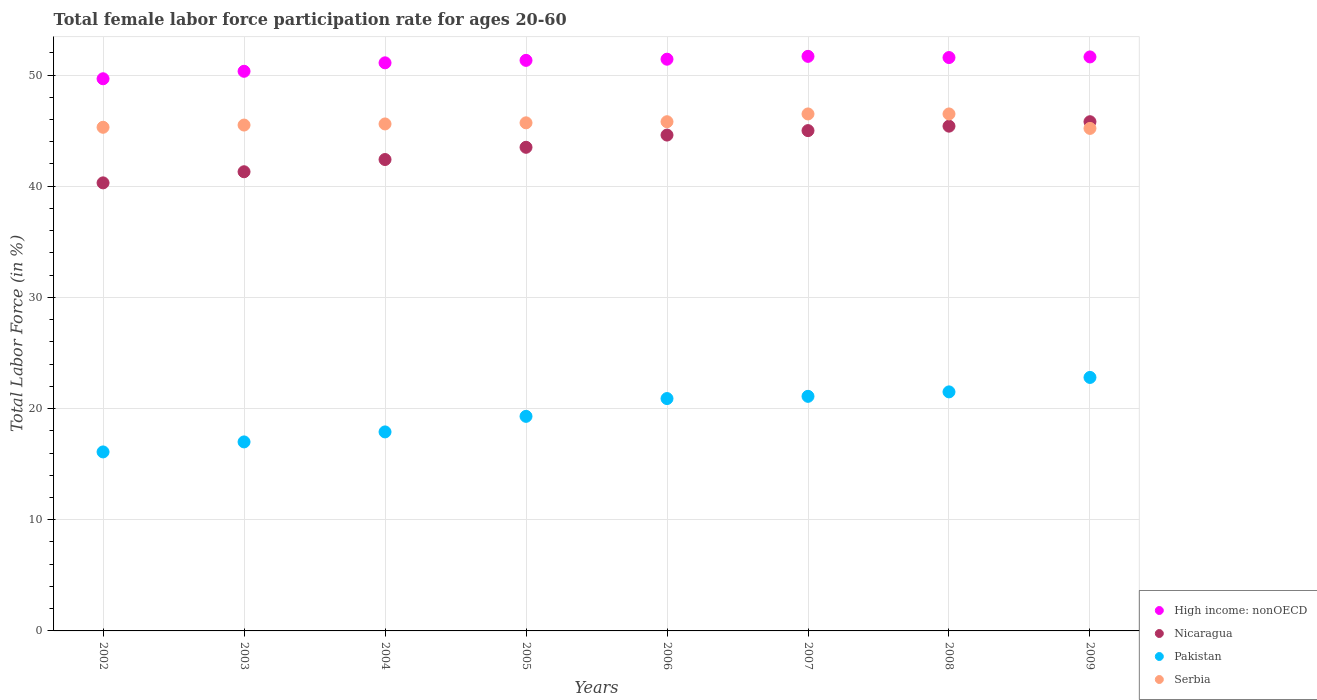How many different coloured dotlines are there?
Your response must be concise. 4. What is the female labor force participation rate in High income: nonOECD in 2003?
Your answer should be compact. 50.34. Across all years, what is the maximum female labor force participation rate in Serbia?
Offer a terse response. 46.5. Across all years, what is the minimum female labor force participation rate in Pakistan?
Ensure brevity in your answer.  16.1. In which year was the female labor force participation rate in Serbia maximum?
Ensure brevity in your answer.  2007. What is the total female labor force participation rate in Pakistan in the graph?
Provide a succinct answer. 156.6. What is the difference between the female labor force participation rate in Nicaragua in 2006 and that in 2008?
Make the answer very short. -0.8. What is the difference between the female labor force participation rate in Serbia in 2009 and the female labor force participation rate in Nicaragua in 2008?
Make the answer very short. -0.2. What is the average female labor force participation rate in Nicaragua per year?
Provide a succinct answer. 43.54. In the year 2005, what is the difference between the female labor force participation rate in Nicaragua and female labor force participation rate in High income: nonOECD?
Offer a terse response. -7.82. What is the ratio of the female labor force participation rate in Serbia in 2006 to that in 2009?
Your answer should be compact. 1.01. What is the difference between the highest and the second highest female labor force participation rate in Pakistan?
Provide a short and direct response. 1.3. What is the difference between the highest and the lowest female labor force participation rate in High income: nonOECD?
Offer a terse response. 2.02. In how many years, is the female labor force participation rate in High income: nonOECD greater than the average female labor force participation rate in High income: nonOECD taken over all years?
Provide a succinct answer. 6. Is it the case that in every year, the sum of the female labor force participation rate in Serbia and female labor force participation rate in Pakistan  is greater than the sum of female labor force participation rate in High income: nonOECD and female labor force participation rate in Nicaragua?
Your response must be concise. No. Is it the case that in every year, the sum of the female labor force participation rate in Nicaragua and female labor force participation rate in Pakistan  is greater than the female labor force participation rate in Serbia?
Give a very brief answer. Yes. How many dotlines are there?
Offer a terse response. 4. How many years are there in the graph?
Your response must be concise. 8. Are the values on the major ticks of Y-axis written in scientific E-notation?
Offer a very short reply. No. Does the graph contain grids?
Provide a succinct answer. Yes. Where does the legend appear in the graph?
Your answer should be very brief. Bottom right. How many legend labels are there?
Give a very brief answer. 4. What is the title of the graph?
Make the answer very short. Total female labor force participation rate for ages 20-60. What is the label or title of the Y-axis?
Give a very brief answer. Total Labor Force (in %). What is the Total Labor Force (in %) of High income: nonOECD in 2002?
Offer a terse response. 49.66. What is the Total Labor Force (in %) of Nicaragua in 2002?
Your answer should be very brief. 40.3. What is the Total Labor Force (in %) in Pakistan in 2002?
Make the answer very short. 16.1. What is the Total Labor Force (in %) in Serbia in 2002?
Your response must be concise. 45.3. What is the Total Labor Force (in %) in High income: nonOECD in 2003?
Ensure brevity in your answer.  50.34. What is the Total Labor Force (in %) of Nicaragua in 2003?
Make the answer very short. 41.3. What is the Total Labor Force (in %) in Pakistan in 2003?
Provide a succinct answer. 17. What is the Total Labor Force (in %) of Serbia in 2003?
Give a very brief answer. 45.5. What is the Total Labor Force (in %) of High income: nonOECD in 2004?
Ensure brevity in your answer.  51.1. What is the Total Labor Force (in %) of Nicaragua in 2004?
Offer a terse response. 42.4. What is the Total Labor Force (in %) of Pakistan in 2004?
Provide a short and direct response. 17.9. What is the Total Labor Force (in %) of Serbia in 2004?
Your answer should be compact. 45.6. What is the Total Labor Force (in %) of High income: nonOECD in 2005?
Your answer should be compact. 51.32. What is the Total Labor Force (in %) of Nicaragua in 2005?
Your answer should be compact. 43.5. What is the Total Labor Force (in %) in Pakistan in 2005?
Keep it short and to the point. 19.3. What is the Total Labor Force (in %) in Serbia in 2005?
Your answer should be very brief. 45.7. What is the Total Labor Force (in %) in High income: nonOECD in 2006?
Give a very brief answer. 51.42. What is the Total Labor Force (in %) in Nicaragua in 2006?
Ensure brevity in your answer.  44.6. What is the Total Labor Force (in %) in Pakistan in 2006?
Your answer should be compact. 20.9. What is the Total Labor Force (in %) in Serbia in 2006?
Give a very brief answer. 45.8. What is the Total Labor Force (in %) in High income: nonOECD in 2007?
Your answer should be very brief. 51.68. What is the Total Labor Force (in %) in Nicaragua in 2007?
Ensure brevity in your answer.  45. What is the Total Labor Force (in %) of Pakistan in 2007?
Give a very brief answer. 21.1. What is the Total Labor Force (in %) in Serbia in 2007?
Make the answer very short. 46.5. What is the Total Labor Force (in %) of High income: nonOECD in 2008?
Your answer should be very brief. 51.57. What is the Total Labor Force (in %) of Nicaragua in 2008?
Your answer should be very brief. 45.4. What is the Total Labor Force (in %) in Serbia in 2008?
Your answer should be compact. 46.5. What is the Total Labor Force (in %) in High income: nonOECD in 2009?
Ensure brevity in your answer.  51.63. What is the Total Labor Force (in %) in Nicaragua in 2009?
Keep it short and to the point. 45.8. What is the Total Labor Force (in %) in Pakistan in 2009?
Offer a terse response. 22.8. What is the Total Labor Force (in %) in Serbia in 2009?
Make the answer very short. 45.2. Across all years, what is the maximum Total Labor Force (in %) of High income: nonOECD?
Your response must be concise. 51.68. Across all years, what is the maximum Total Labor Force (in %) of Nicaragua?
Provide a short and direct response. 45.8. Across all years, what is the maximum Total Labor Force (in %) of Pakistan?
Ensure brevity in your answer.  22.8. Across all years, what is the maximum Total Labor Force (in %) in Serbia?
Your answer should be compact. 46.5. Across all years, what is the minimum Total Labor Force (in %) in High income: nonOECD?
Your answer should be compact. 49.66. Across all years, what is the minimum Total Labor Force (in %) of Nicaragua?
Your answer should be compact. 40.3. Across all years, what is the minimum Total Labor Force (in %) of Pakistan?
Provide a succinct answer. 16.1. Across all years, what is the minimum Total Labor Force (in %) in Serbia?
Give a very brief answer. 45.2. What is the total Total Labor Force (in %) in High income: nonOECD in the graph?
Offer a very short reply. 408.72. What is the total Total Labor Force (in %) of Nicaragua in the graph?
Give a very brief answer. 348.3. What is the total Total Labor Force (in %) in Pakistan in the graph?
Keep it short and to the point. 156.6. What is the total Total Labor Force (in %) in Serbia in the graph?
Offer a very short reply. 366.1. What is the difference between the Total Labor Force (in %) of High income: nonOECD in 2002 and that in 2003?
Offer a very short reply. -0.67. What is the difference between the Total Labor Force (in %) of Nicaragua in 2002 and that in 2003?
Provide a short and direct response. -1. What is the difference between the Total Labor Force (in %) in Pakistan in 2002 and that in 2003?
Your answer should be very brief. -0.9. What is the difference between the Total Labor Force (in %) of High income: nonOECD in 2002 and that in 2004?
Give a very brief answer. -1.43. What is the difference between the Total Labor Force (in %) of Pakistan in 2002 and that in 2004?
Provide a short and direct response. -1.8. What is the difference between the Total Labor Force (in %) of Serbia in 2002 and that in 2004?
Your response must be concise. -0.3. What is the difference between the Total Labor Force (in %) in High income: nonOECD in 2002 and that in 2005?
Your answer should be compact. -1.66. What is the difference between the Total Labor Force (in %) in Nicaragua in 2002 and that in 2005?
Your response must be concise. -3.2. What is the difference between the Total Labor Force (in %) in Pakistan in 2002 and that in 2005?
Offer a very short reply. -3.2. What is the difference between the Total Labor Force (in %) in High income: nonOECD in 2002 and that in 2006?
Make the answer very short. -1.76. What is the difference between the Total Labor Force (in %) in Nicaragua in 2002 and that in 2006?
Provide a short and direct response. -4.3. What is the difference between the Total Labor Force (in %) of Pakistan in 2002 and that in 2006?
Ensure brevity in your answer.  -4.8. What is the difference between the Total Labor Force (in %) in Serbia in 2002 and that in 2006?
Offer a terse response. -0.5. What is the difference between the Total Labor Force (in %) of High income: nonOECD in 2002 and that in 2007?
Provide a succinct answer. -2.02. What is the difference between the Total Labor Force (in %) of Pakistan in 2002 and that in 2007?
Your response must be concise. -5. What is the difference between the Total Labor Force (in %) of Serbia in 2002 and that in 2007?
Make the answer very short. -1.2. What is the difference between the Total Labor Force (in %) of High income: nonOECD in 2002 and that in 2008?
Offer a terse response. -1.91. What is the difference between the Total Labor Force (in %) of Pakistan in 2002 and that in 2008?
Keep it short and to the point. -5.4. What is the difference between the Total Labor Force (in %) in High income: nonOECD in 2002 and that in 2009?
Offer a terse response. -1.96. What is the difference between the Total Labor Force (in %) in Nicaragua in 2002 and that in 2009?
Provide a short and direct response. -5.5. What is the difference between the Total Labor Force (in %) of Pakistan in 2002 and that in 2009?
Your answer should be compact. -6.7. What is the difference between the Total Labor Force (in %) in Serbia in 2002 and that in 2009?
Keep it short and to the point. 0.1. What is the difference between the Total Labor Force (in %) of High income: nonOECD in 2003 and that in 2004?
Keep it short and to the point. -0.76. What is the difference between the Total Labor Force (in %) of High income: nonOECD in 2003 and that in 2005?
Ensure brevity in your answer.  -0.98. What is the difference between the Total Labor Force (in %) in Nicaragua in 2003 and that in 2005?
Your answer should be very brief. -2.2. What is the difference between the Total Labor Force (in %) in High income: nonOECD in 2003 and that in 2006?
Offer a very short reply. -1.09. What is the difference between the Total Labor Force (in %) of Nicaragua in 2003 and that in 2006?
Your response must be concise. -3.3. What is the difference between the Total Labor Force (in %) in High income: nonOECD in 2003 and that in 2007?
Keep it short and to the point. -1.34. What is the difference between the Total Labor Force (in %) in Serbia in 2003 and that in 2007?
Keep it short and to the point. -1. What is the difference between the Total Labor Force (in %) in High income: nonOECD in 2003 and that in 2008?
Provide a short and direct response. -1.24. What is the difference between the Total Labor Force (in %) in Serbia in 2003 and that in 2008?
Your answer should be compact. -1. What is the difference between the Total Labor Force (in %) in High income: nonOECD in 2003 and that in 2009?
Offer a terse response. -1.29. What is the difference between the Total Labor Force (in %) of Nicaragua in 2003 and that in 2009?
Your answer should be compact. -4.5. What is the difference between the Total Labor Force (in %) of Pakistan in 2003 and that in 2009?
Your answer should be compact. -5.8. What is the difference between the Total Labor Force (in %) in High income: nonOECD in 2004 and that in 2005?
Your response must be concise. -0.22. What is the difference between the Total Labor Force (in %) in Nicaragua in 2004 and that in 2005?
Give a very brief answer. -1.1. What is the difference between the Total Labor Force (in %) in High income: nonOECD in 2004 and that in 2006?
Keep it short and to the point. -0.33. What is the difference between the Total Labor Force (in %) in Serbia in 2004 and that in 2006?
Give a very brief answer. -0.2. What is the difference between the Total Labor Force (in %) of High income: nonOECD in 2004 and that in 2007?
Provide a short and direct response. -0.58. What is the difference between the Total Labor Force (in %) of High income: nonOECD in 2004 and that in 2008?
Your response must be concise. -0.48. What is the difference between the Total Labor Force (in %) in Nicaragua in 2004 and that in 2008?
Provide a succinct answer. -3. What is the difference between the Total Labor Force (in %) of Pakistan in 2004 and that in 2008?
Your answer should be compact. -3.6. What is the difference between the Total Labor Force (in %) of High income: nonOECD in 2004 and that in 2009?
Your answer should be compact. -0.53. What is the difference between the Total Labor Force (in %) in Nicaragua in 2004 and that in 2009?
Keep it short and to the point. -3.4. What is the difference between the Total Labor Force (in %) in Pakistan in 2004 and that in 2009?
Your answer should be very brief. -4.9. What is the difference between the Total Labor Force (in %) of Serbia in 2004 and that in 2009?
Offer a very short reply. 0.4. What is the difference between the Total Labor Force (in %) in High income: nonOECD in 2005 and that in 2006?
Your answer should be compact. -0.1. What is the difference between the Total Labor Force (in %) of Nicaragua in 2005 and that in 2006?
Keep it short and to the point. -1.1. What is the difference between the Total Labor Force (in %) in Serbia in 2005 and that in 2006?
Keep it short and to the point. -0.1. What is the difference between the Total Labor Force (in %) of High income: nonOECD in 2005 and that in 2007?
Keep it short and to the point. -0.36. What is the difference between the Total Labor Force (in %) of Pakistan in 2005 and that in 2007?
Your answer should be compact. -1.8. What is the difference between the Total Labor Force (in %) of High income: nonOECD in 2005 and that in 2008?
Provide a short and direct response. -0.25. What is the difference between the Total Labor Force (in %) in Nicaragua in 2005 and that in 2008?
Make the answer very short. -1.9. What is the difference between the Total Labor Force (in %) in Serbia in 2005 and that in 2008?
Offer a very short reply. -0.8. What is the difference between the Total Labor Force (in %) of High income: nonOECD in 2005 and that in 2009?
Offer a terse response. -0.31. What is the difference between the Total Labor Force (in %) in High income: nonOECD in 2006 and that in 2007?
Offer a very short reply. -0.26. What is the difference between the Total Labor Force (in %) of Nicaragua in 2006 and that in 2007?
Offer a terse response. -0.4. What is the difference between the Total Labor Force (in %) of Pakistan in 2006 and that in 2007?
Your answer should be very brief. -0.2. What is the difference between the Total Labor Force (in %) in High income: nonOECD in 2006 and that in 2008?
Provide a short and direct response. -0.15. What is the difference between the Total Labor Force (in %) in Serbia in 2006 and that in 2008?
Your answer should be very brief. -0.7. What is the difference between the Total Labor Force (in %) in High income: nonOECD in 2006 and that in 2009?
Provide a short and direct response. -0.2. What is the difference between the Total Labor Force (in %) of Nicaragua in 2006 and that in 2009?
Ensure brevity in your answer.  -1.2. What is the difference between the Total Labor Force (in %) in High income: nonOECD in 2007 and that in 2008?
Give a very brief answer. 0.11. What is the difference between the Total Labor Force (in %) in Nicaragua in 2007 and that in 2008?
Your answer should be compact. -0.4. What is the difference between the Total Labor Force (in %) in Serbia in 2007 and that in 2008?
Offer a very short reply. 0. What is the difference between the Total Labor Force (in %) of High income: nonOECD in 2007 and that in 2009?
Give a very brief answer. 0.05. What is the difference between the Total Labor Force (in %) of Nicaragua in 2007 and that in 2009?
Your response must be concise. -0.8. What is the difference between the Total Labor Force (in %) in High income: nonOECD in 2008 and that in 2009?
Provide a succinct answer. -0.06. What is the difference between the Total Labor Force (in %) of Pakistan in 2008 and that in 2009?
Give a very brief answer. -1.3. What is the difference between the Total Labor Force (in %) in Serbia in 2008 and that in 2009?
Provide a short and direct response. 1.3. What is the difference between the Total Labor Force (in %) in High income: nonOECD in 2002 and the Total Labor Force (in %) in Nicaragua in 2003?
Your answer should be compact. 8.36. What is the difference between the Total Labor Force (in %) of High income: nonOECD in 2002 and the Total Labor Force (in %) of Pakistan in 2003?
Offer a terse response. 32.66. What is the difference between the Total Labor Force (in %) of High income: nonOECD in 2002 and the Total Labor Force (in %) of Serbia in 2003?
Provide a succinct answer. 4.16. What is the difference between the Total Labor Force (in %) in Nicaragua in 2002 and the Total Labor Force (in %) in Pakistan in 2003?
Ensure brevity in your answer.  23.3. What is the difference between the Total Labor Force (in %) of Nicaragua in 2002 and the Total Labor Force (in %) of Serbia in 2003?
Keep it short and to the point. -5.2. What is the difference between the Total Labor Force (in %) of Pakistan in 2002 and the Total Labor Force (in %) of Serbia in 2003?
Keep it short and to the point. -29.4. What is the difference between the Total Labor Force (in %) of High income: nonOECD in 2002 and the Total Labor Force (in %) of Nicaragua in 2004?
Your response must be concise. 7.26. What is the difference between the Total Labor Force (in %) of High income: nonOECD in 2002 and the Total Labor Force (in %) of Pakistan in 2004?
Offer a very short reply. 31.76. What is the difference between the Total Labor Force (in %) in High income: nonOECD in 2002 and the Total Labor Force (in %) in Serbia in 2004?
Keep it short and to the point. 4.06. What is the difference between the Total Labor Force (in %) in Nicaragua in 2002 and the Total Labor Force (in %) in Pakistan in 2004?
Provide a short and direct response. 22.4. What is the difference between the Total Labor Force (in %) of Pakistan in 2002 and the Total Labor Force (in %) of Serbia in 2004?
Make the answer very short. -29.5. What is the difference between the Total Labor Force (in %) of High income: nonOECD in 2002 and the Total Labor Force (in %) of Nicaragua in 2005?
Offer a terse response. 6.16. What is the difference between the Total Labor Force (in %) in High income: nonOECD in 2002 and the Total Labor Force (in %) in Pakistan in 2005?
Your response must be concise. 30.36. What is the difference between the Total Labor Force (in %) in High income: nonOECD in 2002 and the Total Labor Force (in %) in Serbia in 2005?
Provide a succinct answer. 3.96. What is the difference between the Total Labor Force (in %) of Nicaragua in 2002 and the Total Labor Force (in %) of Pakistan in 2005?
Keep it short and to the point. 21. What is the difference between the Total Labor Force (in %) of Pakistan in 2002 and the Total Labor Force (in %) of Serbia in 2005?
Your answer should be very brief. -29.6. What is the difference between the Total Labor Force (in %) of High income: nonOECD in 2002 and the Total Labor Force (in %) of Nicaragua in 2006?
Offer a terse response. 5.06. What is the difference between the Total Labor Force (in %) in High income: nonOECD in 2002 and the Total Labor Force (in %) in Pakistan in 2006?
Keep it short and to the point. 28.76. What is the difference between the Total Labor Force (in %) of High income: nonOECD in 2002 and the Total Labor Force (in %) of Serbia in 2006?
Your answer should be compact. 3.86. What is the difference between the Total Labor Force (in %) of Pakistan in 2002 and the Total Labor Force (in %) of Serbia in 2006?
Your response must be concise. -29.7. What is the difference between the Total Labor Force (in %) of High income: nonOECD in 2002 and the Total Labor Force (in %) of Nicaragua in 2007?
Ensure brevity in your answer.  4.66. What is the difference between the Total Labor Force (in %) of High income: nonOECD in 2002 and the Total Labor Force (in %) of Pakistan in 2007?
Offer a terse response. 28.56. What is the difference between the Total Labor Force (in %) in High income: nonOECD in 2002 and the Total Labor Force (in %) in Serbia in 2007?
Offer a terse response. 3.16. What is the difference between the Total Labor Force (in %) of Nicaragua in 2002 and the Total Labor Force (in %) of Serbia in 2007?
Keep it short and to the point. -6.2. What is the difference between the Total Labor Force (in %) of Pakistan in 2002 and the Total Labor Force (in %) of Serbia in 2007?
Make the answer very short. -30.4. What is the difference between the Total Labor Force (in %) of High income: nonOECD in 2002 and the Total Labor Force (in %) of Nicaragua in 2008?
Offer a very short reply. 4.26. What is the difference between the Total Labor Force (in %) in High income: nonOECD in 2002 and the Total Labor Force (in %) in Pakistan in 2008?
Offer a terse response. 28.16. What is the difference between the Total Labor Force (in %) in High income: nonOECD in 2002 and the Total Labor Force (in %) in Serbia in 2008?
Provide a succinct answer. 3.16. What is the difference between the Total Labor Force (in %) in Nicaragua in 2002 and the Total Labor Force (in %) in Pakistan in 2008?
Provide a succinct answer. 18.8. What is the difference between the Total Labor Force (in %) of Pakistan in 2002 and the Total Labor Force (in %) of Serbia in 2008?
Provide a short and direct response. -30.4. What is the difference between the Total Labor Force (in %) of High income: nonOECD in 2002 and the Total Labor Force (in %) of Nicaragua in 2009?
Offer a very short reply. 3.86. What is the difference between the Total Labor Force (in %) in High income: nonOECD in 2002 and the Total Labor Force (in %) in Pakistan in 2009?
Your answer should be compact. 26.86. What is the difference between the Total Labor Force (in %) in High income: nonOECD in 2002 and the Total Labor Force (in %) in Serbia in 2009?
Give a very brief answer. 4.46. What is the difference between the Total Labor Force (in %) of Nicaragua in 2002 and the Total Labor Force (in %) of Pakistan in 2009?
Your answer should be very brief. 17.5. What is the difference between the Total Labor Force (in %) of Pakistan in 2002 and the Total Labor Force (in %) of Serbia in 2009?
Give a very brief answer. -29.1. What is the difference between the Total Labor Force (in %) in High income: nonOECD in 2003 and the Total Labor Force (in %) in Nicaragua in 2004?
Give a very brief answer. 7.94. What is the difference between the Total Labor Force (in %) of High income: nonOECD in 2003 and the Total Labor Force (in %) of Pakistan in 2004?
Your answer should be very brief. 32.44. What is the difference between the Total Labor Force (in %) in High income: nonOECD in 2003 and the Total Labor Force (in %) in Serbia in 2004?
Your answer should be very brief. 4.74. What is the difference between the Total Labor Force (in %) in Nicaragua in 2003 and the Total Labor Force (in %) in Pakistan in 2004?
Offer a very short reply. 23.4. What is the difference between the Total Labor Force (in %) of Nicaragua in 2003 and the Total Labor Force (in %) of Serbia in 2004?
Your answer should be very brief. -4.3. What is the difference between the Total Labor Force (in %) of Pakistan in 2003 and the Total Labor Force (in %) of Serbia in 2004?
Make the answer very short. -28.6. What is the difference between the Total Labor Force (in %) in High income: nonOECD in 2003 and the Total Labor Force (in %) in Nicaragua in 2005?
Your answer should be compact. 6.84. What is the difference between the Total Labor Force (in %) of High income: nonOECD in 2003 and the Total Labor Force (in %) of Pakistan in 2005?
Your response must be concise. 31.04. What is the difference between the Total Labor Force (in %) in High income: nonOECD in 2003 and the Total Labor Force (in %) in Serbia in 2005?
Your response must be concise. 4.64. What is the difference between the Total Labor Force (in %) of Nicaragua in 2003 and the Total Labor Force (in %) of Pakistan in 2005?
Make the answer very short. 22. What is the difference between the Total Labor Force (in %) in Pakistan in 2003 and the Total Labor Force (in %) in Serbia in 2005?
Your answer should be compact. -28.7. What is the difference between the Total Labor Force (in %) of High income: nonOECD in 2003 and the Total Labor Force (in %) of Nicaragua in 2006?
Make the answer very short. 5.74. What is the difference between the Total Labor Force (in %) of High income: nonOECD in 2003 and the Total Labor Force (in %) of Pakistan in 2006?
Provide a short and direct response. 29.44. What is the difference between the Total Labor Force (in %) in High income: nonOECD in 2003 and the Total Labor Force (in %) in Serbia in 2006?
Ensure brevity in your answer.  4.54. What is the difference between the Total Labor Force (in %) in Nicaragua in 2003 and the Total Labor Force (in %) in Pakistan in 2006?
Ensure brevity in your answer.  20.4. What is the difference between the Total Labor Force (in %) of Pakistan in 2003 and the Total Labor Force (in %) of Serbia in 2006?
Make the answer very short. -28.8. What is the difference between the Total Labor Force (in %) in High income: nonOECD in 2003 and the Total Labor Force (in %) in Nicaragua in 2007?
Keep it short and to the point. 5.34. What is the difference between the Total Labor Force (in %) of High income: nonOECD in 2003 and the Total Labor Force (in %) of Pakistan in 2007?
Provide a succinct answer. 29.24. What is the difference between the Total Labor Force (in %) of High income: nonOECD in 2003 and the Total Labor Force (in %) of Serbia in 2007?
Provide a succinct answer. 3.84. What is the difference between the Total Labor Force (in %) in Nicaragua in 2003 and the Total Labor Force (in %) in Pakistan in 2007?
Offer a very short reply. 20.2. What is the difference between the Total Labor Force (in %) in Pakistan in 2003 and the Total Labor Force (in %) in Serbia in 2007?
Make the answer very short. -29.5. What is the difference between the Total Labor Force (in %) of High income: nonOECD in 2003 and the Total Labor Force (in %) of Nicaragua in 2008?
Provide a succinct answer. 4.94. What is the difference between the Total Labor Force (in %) of High income: nonOECD in 2003 and the Total Labor Force (in %) of Pakistan in 2008?
Offer a terse response. 28.84. What is the difference between the Total Labor Force (in %) in High income: nonOECD in 2003 and the Total Labor Force (in %) in Serbia in 2008?
Keep it short and to the point. 3.84. What is the difference between the Total Labor Force (in %) of Nicaragua in 2003 and the Total Labor Force (in %) of Pakistan in 2008?
Your response must be concise. 19.8. What is the difference between the Total Labor Force (in %) of Nicaragua in 2003 and the Total Labor Force (in %) of Serbia in 2008?
Your answer should be compact. -5.2. What is the difference between the Total Labor Force (in %) of Pakistan in 2003 and the Total Labor Force (in %) of Serbia in 2008?
Provide a succinct answer. -29.5. What is the difference between the Total Labor Force (in %) of High income: nonOECD in 2003 and the Total Labor Force (in %) of Nicaragua in 2009?
Your response must be concise. 4.54. What is the difference between the Total Labor Force (in %) in High income: nonOECD in 2003 and the Total Labor Force (in %) in Pakistan in 2009?
Your answer should be compact. 27.54. What is the difference between the Total Labor Force (in %) of High income: nonOECD in 2003 and the Total Labor Force (in %) of Serbia in 2009?
Ensure brevity in your answer.  5.14. What is the difference between the Total Labor Force (in %) in Nicaragua in 2003 and the Total Labor Force (in %) in Pakistan in 2009?
Provide a short and direct response. 18.5. What is the difference between the Total Labor Force (in %) in Nicaragua in 2003 and the Total Labor Force (in %) in Serbia in 2009?
Your answer should be compact. -3.9. What is the difference between the Total Labor Force (in %) in Pakistan in 2003 and the Total Labor Force (in %) in Serbia in 2009?
Offer a terse response. -28.2. What is the difference between the Total Labor Force (in %) in High income: nonOECD in 2004 and the Total Labor Force (in %) in Nicaragua in 2005?
Provide a short and direct response. 7.6. What is the difference between the Total Labor Force (in %) of High income: nonOECD in 2004 and the Total Labor Force (in %) of Pakistan in 2005?
Give a very brief answer. 31.8. What is the difference between the Total Labor Force (in %) in High income: nonOECD in 2004 and the Total Labor Force (in %) in Serbia in 2005?
Provide a short and direct response. 5.4. What is the difference between the Total Labor Force (in %) of Nicaragua in 2004 and the Total Labor Force (in %) of Pakistan in 2005?
Give a very brief answer. 23.1. What is the difference between the Total Labor Force (in %) in Pakistan in 2004 and the Total Labor Force (in %) in Serbia in 2005?
Keep it short and to the point. -27.8. What is the difference between the Total Labor Force (in %) in High income: nonOECD in 2004 and the Total Labor Force (in %) in Nicaragua in 2006?
Provide a short and direct response. 6.5. What is the difference between the Total Labor Force (in %) of High income: nonOECD in 2004 and the Total Labor Force (in %) of Pakistan in 2006?
Keep it short and to the point. 30.2. What is the difference between the Total Labor Force (in %) in High income: nonOECD in 2004 and the Total Labor Force (in %) in Serbia in 2006?
Give a very brief answer. 5.3. What is the difference between the Total Labor Force (in %) in Nicaragua in 2004 and the Total Labor Force (in %) in Pakistan in 2006?
Your answer should be very brief. 21.5. What is the difference between the Total Labor Force (in %) of Nicaragua in 2004 and the Total Labor Force (in %) of Serbia in 2006?
Provide a short and direct response. -3.4. What is the difference between the Total Labor Force (in %) in Pakistan in 2004 and the Total Labor Force (in %) in Serbia in 2006?
Your answer should be very brief. -27.9. What is the difference between the Total Labor Force (in %) in High income: nonOECD in 2004 and the Total Labor Force (in %) in Nicaragua in 2007?
Offer a very short reply. 6.1. What is the difference between the Total Labor Force (in %) of High income: nonOECD in 2004 and the Total Labor Force (in %) of Pakistan in 2007?
Your answer should be very brief. 30. What is the difference between the Total Labor Force (in %) in High income: nonOECD in 2004 and the Total Labor Force (in %) in Serbia in 2007?
Your response must be concise. 4.6. What is the difference between the Total Labor Force (in %) in Nicaragua in 2004 and the Total Labor Force (in %) in Pakistan in 2007?
Your answer should be very brief. 21.3. What is the difference between the Total Labor Force (in %) in Pakistan in 2004 and the Total Labor Force (in %) in Serbia in 2007?
Your response must be concise. -28.6. What is the difference between the Total Labor Force (in %) in High income: nonOECD in 2004 and the Total Labor Force (in %) in Nicaragua in 2008?
Your answer should be very brief. 5.7. What is the difference between the Total Labor Force (in %) of High income: nonOECD in 2004 and the Total Labor Force (in %) of Pakistan in 2008?
Provide a short and direct response. 29.6. What is the difference between the Total Labor Force (in %) in High income: nonOECD in 2004 and the Total Labor Force (in %) in Serbia in 2008?
Your answer should be compact. 4.6. What is the difference between the Total Labor Force (in %) in Nicaragua in 2004 and the Total Labor Force (in %) in Pakistan in 2008?
Your response must be concise. 20.9. What is the difference between the Total Labor Force (in %) of Nicaragua in 2004 and the Total Labor Force (in %) of Serbia in 2008?
Give a very brief answer. -4.1. What is the difference between the Total Labor Force (in %) of Pakistan in 2004 and the Total Labor Force (in %) of Serbia in 2008?
Ensure brevity in your answer.  -28.6. What is the difference between the Total Labor Force (in %) in High income: nonOECD in 2004 and the Total Labor Force (in %) in Nicaragua in 2009?
Your answer should be compact. 5.3. What is the difference between the Total Labor Force (in %) of High income: nonOECD in 2004 and the Total Labor Force (in %) of Pakistan in 2009?
Provide a succinct answer. 28.3. What is the difference between the Total Labor Force (in %) of High income: nonOECD in 2004 and the Total Labor Force (in %) of Serbia in 2009?
Give a very brief answer. 5.9. What is the difference between the Total Labor Force (in %) of Nicaragua in 2004 and the Total Labor Force (in %) of Pakistan in 2009?
Offer a very short reply. 19.6. What is the difference between the Total Labor Force (in %) of Nicaragua in 2004 and the Total Labor Force (in %) of Serbia in 2009?
Provide a succinct answer. -2.8. What is the difference between the Total Labor Force (in %) of Pakistan in 2004 and the Total Labor Force (in %) of Serbia in 2009?
Your answer should be compact. -27.3. What is the difference between the Total Labor Force (in %) of High income: nonOECD in 2005 and the Total Labor Force (in %) of Nicaragua in 2006?
Your answer should be compact. 6.72. What is the difference between the Total Labor Force (in %) of High income: nonOECD in 2005 and the Total Labor Force (in %) of Pakistan in 2006?
Your response must be concise. 30.42. What is the difference between the Total Labor Force (in %) of High income: nonOECD in 2005 and the Total Labor Force (in %) of Serbia in 2006?
Offer a terse response. 5.52. What is the difference between the Total Labor Force (in %) in Nicaragua in 2005 and the Total Labor Force (in %) in Pakistan in 2006?
Make the answer very short. 22.6. What is the difference between the Total Labor Force (in %) in Pakistan in 2005 and the Total Labor Force (in %) in Serbia in 2006?
Ensure brevity in your answer.  -26.5. What is the difference between the Total Labor Force (in %) of High income: nonOECD in 2005 and the Total Labor Force (in %) of Nicaragua in 2007?
Offer a very short reply. 6.32. What is the difference between the Total Labor Force (in %) in High income: nonOECD in 2005 and the Total Labor Force (in %) in Pakistan in 2007?
Your answer should be very brief. 30.22. What is the difference between the Total Labor Force (in %) of High income: nonOECD in 2005 and the Total Labor Force (in %) of Serbia in 2007?
Ensure brevity in your answer.  4.82. What is the difference between the Total Labor Force (in %) of Nicaragua in 2005 and the Total Labor Force (in %) of Pakistan in 2007?
Your response must be concise. 22.4. What is the difference between the Total Labor Force (in %) of Pakistan in 2005 and the Total Labor Force (in %) of Serbia in 2007?
Provide a succinct answer. -27.2. What is the difference between the Total Labor Force (in %) of High income: nonOECD in 2005 and the Total Labor Force (in %) of Nicaragua in 2008?
Your response must be concise. 5.92. What is the difference between the Total Labor Force (in %) in High income: nonOECD in 2005 and the Total Labor Force (in %) in Pakistan in 2008?
Offer a terse response. 29.82. What is the difference between the Total Labor Force (in %) of High income: nonOECD in 2005 and the Total Labor Force (in %) of Serbia in 2008?
Give a very brief answer. 4.82. What is the difference between the Total Labor Force (in %) of Nicaragua in 2005 and the Total Labor Force (in %) of Pakistan in 2008?
Offer a very short reply. 22. What is the difference between the Total Labor Force (in %) in Pakistan in 2005 and the Total Labor Force (in %) in Serbia in 2008?
Provide a short and direct response. -27.2. What is the difference between the Total Labor Force (in %) of High income: nonOECD in 2005 and the Total Labor Force (in %) of Nicaragua in 2009?
Provide a succinct answer. 5.52. What is the difference between the Total Labor Force (in %) of High income: nonOECD in 2005 and the Total Labor Force (in %) of Pakistan in 2009?
Make the answer very short. 28.52. What is the difference between the Total Labor Force (in %) in High income: nonOECD in 2005 and the Total Labor Force (in %) in Serbia in 2009?
Your response must be concise. 6.12. What is the difference between the Total Labor Force (in %) of Nicaragua in 2005 and the Total Labor Force (in %) of Pakistan in 2009?
Provide a succinct answer. 20.7. What is the difference between the Total Labor Force (in %) in Pakistan in 2005 and the Total Labor Force (in %) in Serbia in 2009?
Your answer should be compact. -25.9. What is the difference between the Total Labor Force (in %) of High income: nonOECD in 2006 and the Total Labor Force (in %) of Nicaragua in 2007?
Your answer should be very brief. 6.42. What is the difference between the Total Labor Force (in %) of High income: nonOECD in 2006 and the Total Labor Force (in %) of Pakistan in 2007?
Keep it short and to the point. 30.32. What is the difference between the Total Labor Force (in %) in High income: nonOECD in 2006 and the Total Labor Force (in %) in Serbia in 2007?
Your answer should be very brief. 4.92. What is the difference between the Total Labor Force (in %) in Nicaragua in 2006 and the Total Labor Force (in %) in Serbia in 2007?
Give a very brief answer. -1.9. What is the difference between the Total Labor Force (in %) of Pakistan in 2006 and the Total Labor Force (in %) of Serbia in 2007?
Your answer should be very brief. -25.6. What is the difference between the Total Labor Force (in %) of High income: nonOECD in 2006 and the Total Labor Force (in %) of Nicaragua in 2008?
Your answer should be very brief. 6.02. What is the difference between the Total Labor Force (in %) of High income: nonOECD in 2006 and the Total Labor Force (in %) of Pakistan in 2008?
Your response must be concise. 29.92. What is the difference between the Total Labor Force (in %) of High income: nonOECD in 2006 and the Total Labor Force (in %) of Serbia in 2008?
Keep it short and to the point. 4.92. What is the difference between the Total Labor Force (in %) of Nicaragua in 2006 and the Total Labor Force (in %) of Pakistan in 2008?
Give a very brief answer. 23.1. What is the difference between the Total Labor Force (in %) in Pakistan in 2006 and the Total Labor Force (in %) in Serbia in 2008?
Offer a very short reply. -25.6. What is the difference between the Total Labor Force (in %) in High income: nonOECD in 2006 and the Total Labor Force (in %) in Nicaragua in 2009?
Keep it short and to the point. 5.62. What is the difference between the Total Labor Force (in %) of High income: nonOECD in 2006 and the Total Labor Force (in %) of Pakistan in 2009?
Keep it short and to the point. 28.62. What is the difference between the Total Labor Force (in %) of High income: nonOECD in 2006 and the Total Labor Force (in %) of Serbia in 2009?
Offer a very short reply. 6.22. What is the difference between the Total Labor Force (in %) in Nicaragua in 2006 and the Total Labor Force (in %) in Pakistan in 2009?
Keep it short and to the point. 21.8. What is the difference between the Total Labor Force (in %) of Nicaragua in 2006 and the Total Labor Force (in %) of Serbia in 2009?
Offer a very short reply. -0.6. What is the difference between the Total Labor Force (in %) of Pakistan in 2006 and the Total Labor Force (in %) of Serbia in 2009?
Your answer should be very brief. -24.3. What is the difference between the Total Labor Force (in %) of High income: nonOECD in 2007 and the Total Labor Force (in %) of Nicaragua in 2008?
Make the answer very short. 6.28. What is the difference between the Total Labor Force (in %) in High income: nonOECD in 2007 and the Total Labor Force (in %) in Pakistan in 2008?
Offer a terse response. 30.18. What is the difference between the Total Labor Force (in %) in High income: nonOECD in 2007 and the Total Labor Force (in %) in Serbia in 2008?
Give a very brief answer. 5.18. What is the difference between the Total Labor Force (in %) in Pakistan in 2007 and the Total Labor Force (in %) in Serbia in 2008?
Your response must be concise. -25.4. What is the difference between the Total Labor Force (in %) of High income: nonOECD in 2007 and the Total Labor Force (in %) of Nicaragua in 2009?
Provide a succinct answer. 5.88. What is the difference between the Total Labor Force (in %) of High income: nonOECD in 2007 and the Total Labor Force (in %) of Pakistan in 2009?
Your answer should be compact. 28.88. What is the difference between the Total Labor Force (in %) in High income: nonOECD in 2007 and the Total Labor Force (in %) in Serbia in 2009?
Your answer should be compact. 6.48. What is the difference between the Total Labor Force (in %) of Nicaragua in 2007 and the Total Labor Force (in %) of Pakistan in 2009?
Offer a terse response. 22.2. What is the difference between the Total Labor Force (in %) of Nicaragua in 2007 and the Total Labor Force (in %) of Serbia in 2009?
Keep it short and to the point. -0.2. What is the difference between the Total Labor Force (in %) in Pakistan in 2007 and the Total Labor Force (in %) in Serbia in 2009?
Your answer should be very brief. -24.1. What is the difference between the Total Labor Force (in %) in High income: nonOECD in 2008 and the Total Labor Force (in %) in Nicaragua in 2009?
Offer a very short reply. 5.77. What is the difference between the Total Labor Force (in %) of High income: nonOECD in 2008 and the Total Labor Force (in %) of Pakistan in 2009?
Give a very brief answer. 28.77. What is the difference between the Total Labor Force (in %) in High income: nonOECD in 2008 and the Total Labor Force (in %) in Serbia in 2009?
Your response must be concise. 6.37. What is the difference between the Total Labor Force (in %) of Nicaragua in 2008 and the Total Labor Force (in %) of Pakistan in 2009?
Keep it short and to the point. 22.6. What is the difference between the Total Labor Force (in %) of Pakistan in 2008 and the Total Labor Force (in %) of Serbia in 2009?
Your answer should be compact. -23.7. What is the average Total Labor Force (in %) of High income: nonOECD per year?
Your response must be concise. 51.09. What is the average Total Labor Force (in %) of Nicaragua per year?
Offer a terse response. 43.54. What is the average Total Labor Force (in %) in Pakistan per year?
Provide a short and direct response. 19.57. What is the average Total Labor Force (in %) of Serbia per year?
Offer a terse response. 45.76. In the year 2002, what is the difference between the Total Labor Force (in %) in High income: nonOECD and Total Labor Force (in %) in Nicaragua?
Your response must be concise. 9.36. In the year 2002, what is the difference between the Total Labor Force (in %) of High income: nonOECD and Total Labor Force (in %) of Pakistan?
Make the answer very short. 33.56. In the year 2002, what is the difference between the Total Labor Force (in %) in High income: nonOECD and Total Labor Force (in %) in Serbia?
Your response must be concise. 4.36. In the year 2002, what is the difference between the Total Labor Force (in %) in Nicaragua and Total Labor Force (in %) in Pakistan?
Keep it short and to the point. 24.2. In the year 2002, what is the difference between the Total Labor Force (in %) of Pakistan and Total Labor Force (in %) of Serbia?
Ensure brevity in your answer.  -29.2. In the year 2003, what is the difference between the Total Labor Force (in %) in High income: nonOECD and Total Labor Force (in %) in Nicaragua?
Provide a short and direct response. 9.04. In the year 2003, what is the difference between the Total Labor Force (in %) in High income: nonOECD and Total Labor Force (in %) in Pakistan?
Your response must be concise. 33.34. In the year 2003, what is the difference between the Total Labor Force (in %) in High income: nonOECD and Total Labor Force (in %) in Serbia?
Offer a terse response. 4.84. In the year 2003, what is the difference between the Total Labor Force (in %) in Nicaragua and Total Labor Force (in %) in Pakistan?
Your answer should be very brief. 24.3. In the year 2003, what is the difference between the Total Labor Force (in %) in Nicaragua and Total Labor Force (in %) in Serbia?
Give a very brief answer. -4.2. In the year 2003, what is the difference between the Total Labor Force (in %) of Pakistan and Total Labor Force (in %) of Serbia?
Provide a short and direct response. -28.5. In the year 2004, what is the difference between the Total Labor Force (in %) in High income: nonOECD and Total Labor Force (in %) in Nicaragua?
Your response must be concise. 8.7. In the year 2004, what is the difference between the Total Labor Force (in %) in High income: nonOECD and Total Labor Force (in %) in Pakistan?
Keep it short and to the point. 33.2. In the year 2004, what is the difference between the Total Labor Force (in %) in High income: nonOECD and Total Labor Force (in %) in Serbia?
Offer a very short reply. 5.5. In the year 2004, what is the difference between the Total Labor Force (in %) of Nicaragua and Total Labor Force (in %) of Serbia?
Give a very brief answer. -3.2. In the year 2004, what is the difference between the Total Labor Force (in %) of Pakistan and Total Labor Force (in %) of Serbia?
Keep it short and to the point. -27.7. In the year 2005, what is the difference between the Total Labor Force (in %) of High income: nonOECD and Total Labor Force (in %) of Nicaragua?
Your answer should be compact. 7.82. In the year 2005, what is the difference between the Total Labor Force (in %) of High income: nonOECD and Total Labor Force (in %) of Pakistan?
Provide a short and direct response. 32.02. In the year 2005, what is the difference between the Total Labor Force (in %) of High income: nonOECD and Total Labor Force (in %) of Serbia?
Your response must be concise. 5.62. In the year 2005, what is the difference between the Total Labor Force (in %) of Nicaragua and Total Labor Force (in %) of Pakistan?
Offer a very short reply. 24.2. In the year 2005, what is the difference between the Total Labor Force (in %) of Nicaragua and Total Labor Force (in %) of Serbia?
Offer a terse response. -2.2. In the year 2005, what is the difference between the Total Labor Force (in %) in Pakistan and Total Labor Force (in %) in Serbia?
Provide a succinct answer. -26.4. In the year 2006, what is the difference between the Total Labor Force (in %) of High income: nonOECD and Total Labor Force (in %) of Nicaragua?
Offer a very short reply. 6.82. In the year 2006, what is the difference between the Total Labor Force (in %) of High income: nonOECD and Total Labor Force (in %) of Pakistan?
Keep it short and to the point. 30.52. In the year 2006, what is the difference between the Total Labor Force (in %) in High income: nonOECD and Total Labor Force (in %) in Serbia?
Provide a succinct answer. 5.62. In the year 2006, what is the difference between the Total Labor Force (in %) of Nicaragua and Total Labor Force (in %) of Pakistan?
Keep it short and to the point. 23.7. In the year 2006, what is the difference between the Total Labor Force (in %) in Pakistan and Total Labor Force (in %) in Serbia?
Offer a very short reply. -24.9. In the year 2007, what is the difference between the Total Labor Force (in %) in High income: nonOECD and Total Labor Force (in %) in Nicaragua?
Keep it short and to the point. 6.68. In the year 2007, what is the difference between the Total Labor Force (in %) of High income: nonOECD and Total Labor Force (in %) of Pakistan?
Your answer should be very brief. 30.58. In the year 2007, what is the difference between the Total Labor Force (in %) of High income: nonOECD and Total Labor Force (in %) of Serbia?
Your answer should be very brief. 5.18. In the year 2007, what is the difference between the Total Labor Force (in %) in Nicaragua and Total Labor Force (in %) in Pakistan?
Keep it short and to the point. 23.9. In the year 2007, what is the difference between the Total Labor Force (in %) of Nicaragua and Total Labor Force (in %) of Serbia?
Your answer should be very brief. -1.5. In the year 2007, what is the difference between the Total Labor Force (in %) of Pakistan and Total Labor Force (in %) of Serbia?
Provide a short and direct response. -25.4. In the year 2008, what is the difference between the Total Labor Force (in %) in High income: nonOECD and Total Labor Force (in %) in Nicaragua?
Provide a short and direct response. 6.17. In the year 2008, what is the difference between the Total Labor Force (in %) of High income: nonOECD and Total Labor Force (in %) of Pakistan?
Give a very brief answer. 30.07. In the year 2008, what is the difference between the Total Labor Force (in %) of High income: nonOECD and Total Labor Force (in %) of Serbia?
Ensure brevity in your answer.  5.07. In the year 2008, what is the difference between the Total Labor Force (in %) of Nicaragua and Total Labor Force (in %) of Pakistan?
Provide a short and direct response. 23.9. In the year 2008, what is the difference between the Total Labor Force (in %) of Nicaragua and Total Labor Force (in %) of Serbia?
Your answer should be very brief. -1.1. In the year 2008, what is the difference between the Total Labor Force (in %) in Pakistan and Total Labor Force (in %) in Serbia?
Keep it short and to the point. -25. In the year 2009, what is the difference between the Total Labor Force (in %) in High income: nonOECD and Total Labor Force (in %) in Nicaragua?
Give a very brief answer. 5.83. In the year 2009, what is the difference between the Total Labor Force (in %) in High income: nonOECD and Total Labor Force (in %) in Pakistan?
Provide a succinct answer. 28.83. In the year 2009, what is the difference between the Total Labor Force (in %) in High income: nonOECD and Total Labor Force (in %) in Serbia?
Offer a terse response. 6.43. In the year 2009, what is the difference between the Total Labor Force (in %) in Nicaragua and Total Labor Force (in %) in Pakistan?
Keep it short and to the point. 23. In the year 2009, what is the difference between the Total Labor Force (in %) in Nicaragua and Total Labor Force (in %) in Serbia?
Provide a short and direct response. 0.6. In the year 2009, what is the difference between the Total Labor Force (in %) in Pakistan and Total Labor Force (in %) in Serbia?
Offer a terse response. -22.4. What is the ratio of the Total Labor Force (in %) in High income: nonOECD in 2002 to that in 2003?
Offer a terse response. 0.99. What is the ratio of the Total Labor Force (in %) of Nicaragua in 2002 to that in 2003?
Make the answer very short. 0.98. What is the ratio of the Total Labor Force (in %) in Pakistan in 2002 to that in 2003?
Provide a short and direct response. 0.95. What is the ratio of the Total Labor Force (in %) of Serbia in 2002 to that in 2003?
Your response must be concise. 1. What is the ratio of the Total Labor Force (in %) in High income: nonOECD in 2002 to that in 2004?
Your answer should be compact. 0.97. What is the ratio of the Total Labor Force (in %) of Nicaragua in 2002 to that in 2004?
Provide a succinct answer. 0.95. What is the ratio of the Total Labor Force (in %) of Pakistan in 2002 to that in 2004?
Make the answer very short. 0.9. What is the ratio of the Total Labor Force (in %) in Serbia in 2002 to that in 2004?
Offer a terse response. 0.99. What is the ratio of the Total Labor Force (in %) of Nicaragua in 2002 to that in 2005?
Keep it short and to the point. 0.93. What is the ratio of the Total Labor Force (in %) in Pakistan in 2002 to that in 2005?
Your response must be concise. 0.83. What is the ratio of the Total Labor Force (in %) in Serbia in 2002 to that in 2005?
Ensure brevity in your answer.  0.99. What is the ratio of the Total Labor Force (in %) in High income: nonOECD in 2002 to that in 2006?
Provide a short and direct response. 0.97. What is the ratio of the Total Labor Force (in %) in Nicaragua in 2002 to that in 2006?
Your answer should be compact. 0.9. What is the ratio of the Total Labor Force (in %) in Pakistan in 2002 to that in 2006?
Your answer should be very brief. 0.77. What is the ratio of the Total Labor Force (in %) of Serbia in 2002 to that in 2006?
Provide a succinct answer. 0.99. What is the ratio of the Total Labor Force (in %) of Nicaragua in 2002 to that in 2007?
Your response must be concise. 0.9. What is the ratio of the Total Labor Force (in %) in Pakistan in 2002 to that in 2007?
Offer a terse response. 0.76. What is the ratio of the Total Labor Force (in %) in Serbia in 2002 to that in 2007?
Provide a short and direct response. 0.97. What is the ratio of the Total Labor Force (in %) in Nicaragua in 2002 to that in 2008?
Your response must be concise. 0.89. What is the ratio of the Total Labor Force (in %) in Pakistan in 2002 to that in 2008?
Give a very brief answer. 0.75. What is the ratio of the Total Labor Force (in %) in Serbia in 2002 to that in 2008?
Keep it short and to the point. 0.97. What is the ratio of the Total Labor Force (in %) of High income: nonOECD in 2002 to that in 2009?
Offer a terse response. 0.96. What is the ratio of the Total Labor Force (in %) in Nicaragua in 2002 to that in 2009?
Provide a succinct answer. 0.88. What is the ratio of the Total Labor Force (in %) of Pakistan in 2002 to that in 2009?
Ensure brevity in your answer.  0.71. What is the ratio of the Total Labor Force (in %) in High income: nonOECD in 2003 to that in 2004?
Offer a terse response. 0.99. What is the ratio of the Total Labor Force (in %) in Nicaragua in 2003 to that in 2004?
Offer a terse response. 0.97. What is the ratio of the Total Labor Force (in %) of Pakistan in 2003 to that in 2004?
Your response must be concise. 0.95. What is the ratio of the Total Labor Force (in %) in High income: nonOECD in 2003 to that in 2005?
Provide a short and direct response. 0.98. What is the ratio of the Total Labor Force (in %) in Nicaragua in 2003 to that in 2005?
Offer a very short reply. 0.95. What is the ratio of the Total Labor Force (in %) of Pakistan in 2003 to that in 2005?
Offer a terse response. 0.88. What is the ratio of the Total Labor Force (in %) in High income: nonOECD in 2003 to that in 2006?
Offer a very short reply. 0.98. What is the ratio of the Total Labor Force (in %) in Nicaragua in 2003 to that in 2006?
Provide a short and direct response. 0.93. What is the ratio of the Total Labor Force (in %) in Pakistan in 2003 to that in 2006?
Your answer should be compact. 0.81. What is the ratio of the Total Labor Force (in %) of Serbia in 2003 to that in 2006?
Offer a terse response. 0.99. What is the ratio of the Total Labor Force (in %) in High income: nonOECD in 2003 to that in 2007?
Your answer should be compact. 0.97. What is the ratio of the Total Labor Force (in %) of Nicaragua in 2003 to that in 2007?
Give a very brief answer. 0.92. What is the ratio of the Total Labor Force (in %) of Pakistan in 2003 to that in 2007?
Offer a terse response. 0.81. What is the ratio of the Total Labor Force (in %) of Serbia in 2003 to that in 2007?
Keep it short and to the point. 0.98. What is the ratio of the Total Labor Force (in %) of High income: nonOECD in 2003 to that in 2008?
Your answer should be compact. 0.98. What is the ratio of the Total Labor Force (in %) of Nicaragua in 2003 to that in 2008?
Give a very brief answer. 0.91. What is the ratio of the Total Labor Force (in %) in Pakistan in 2003 to that in 2008?
Provide a succinct answer. 0.79. What is the ratio of the Total Labor Force (in %) in Serbia in 2003 to that in 2008?
Offer a very short reply. 0.98. What is the ratio of the Total Labor Force (in %) in High income: nonOECD in 2003 to that in 2009?
Offer a very short reply. 0.97. What is the ratio of the Total Labor Force (in %) of Nicaragua in 2003 to that in 2009?
Offer a very short reply. 0.9. What is the ratio of the Total Labor Force (in %) of Pakistan in 2003 to that in 2009?
Your answer should be compact. 0.75. What is the ratio of the Total Labor Force (in %) in Serbia in 2003 to that in 2009?
Your answer should be very brief. 1.01. What is the ratio of the Total Labor Force (in %) in High income: nonOECD in 2004 to that in 2005?
Ensure brevity in your answer.  1. What is the ratio of the Total Labor Force (in %) of Nicaragua in 2004 to that in 2005?
Your response must be concise. 0.97. What is the ratio of the Total Labor Force (in %) in Pakistan in 2004 to that in 2005?
Ensure brevity in your answer.  0.93. What is the ratio of the Total Labor Force (in %) of High income: nonOECD in 2004 to that in 2006?
Your response must be concise. 0.99. What is the ratio of the Total Labor Force (in %) in Nicaragua in 2004 to that in 2006?
Make the answer very short. 0.95. What is the ratio of the Total Labor Force (in %) of Pakistan in 2004 to that in 2006?
Make the answer very short. 0.86. What is the ratio of the Total Labor Force (in %) of Serbia in 2004 to that in 2006?
Your answer should be compact. 1. What is the ratio of the Total Labor Force (in %) in High income: nonOECD in 2004 to that in 2007?
Ensure brevity in your answer.  0.99. What is the ratio of the Total Labor Force (in %) in Nicaragua in 2004 to that in 2007?
Give a very brief answer. 0.94. What is the ratio of the Total Labor Force (in %) of Pakistan in 2004 to that in 2007?
Keep it short and to the point. 0.85. What is the ratio of the Total Labor Force (in %) of Serbia in 2004 to that in 2007?
Provide a succinct answer. 0.98. What is the ratio of the Total Labor Force (in %) of Nicaragua in 2004 to that in 2008?
Offer a terse response. 0.93. What is the ratio of the Total Labor Force (in %) in Pakistan in 2004 to that in 2008?
Give a very brief answer. 0.83. What is the ratio of the Total Labor Force (in %) in Serbia in 2004 to that in 2008?
Offer a terse response. 0.98. What is the ratio of the Total Labor Force (in %) of Nicaragua in 2004 to that in 2009?
Offer a very short reply. 0.93. What is the ratio of the Total Labor Force (in %) in Pakistan in 2004 to that in 2009?
Your answer should be compact. 0.79. What is the ratio of the Total Labor Force (in %) in Serbia in 2004 to that in 2009?
Offer a very short reply. 1.01. What is the ratio of the Total Labor Force (in %) in High income: nonOECD in 2005 to that in 2006?
Offer a very short reply. 1. What is the ratio of the Total Labor Force (in %) of Nicaragua in 2005 to that in 2006?
Give a very brief answer. 0.98. What is the ratio of the Total Labor Force (in %) of Pakistan in 2005 to that in 2006?
Keep it short and to the point. 0.92. What is the ratio of the Total Labor Force (in %) of High income: nonOECD in 2005 to that in 2007?
Ensure brevity in your answer.  0.99. What is the ratio of the Total Labor Force (in %) of Nicaragua in 2005 to that in 2007?
Offer a terse response. 0.97. What is the ratio of the Total Labor Force (in %) in Pakistan in 2005 to that in 2007?
Your answer should be very brief. 0.91. What is the ratio of the Total Labor Force (in %) of Serbia in 2005 to that in 2007?
Give a very brief answer. 0.98. What is the ratio of the Total Labor Force (in %) of Nicaragua in 2005 to that in 2008?
Give a very brief answer. 0.96. What is the ratio of the Total Labor Force (in %) in Pakistan in 2005 to that in 2008?
Make the answer very short. 0.9. What is the ratio of the Total Labor Force (in %) in Serbia in 2005 to that in 2008?
Your answer should be very brief. 0.98. What is the ratio of the Total Labor Force (in %) of Nicaragua in 2005 to that in 2009?
Give a very brief answer. 0.95. What is the ratio of the Total Labor Force (in %) of Pakistan in 2005 to that in 2009?
Provide a succinct answer. 0.85. What is the ratio of the Total Labor Force (in %) of Serbia in 2005 to that in 2009?
Offer a very short reply. 1.01. What is the ratio of the Total Labor Force (in %) of High income: nonOECD in 2006 to that in 2007?
Your answer should be very brief. 1. What is the ratio of the Total Labor Force (in %) of Serbia in 2006 to that in 2007?
Keep it short and to the point. 0.98. What is the ratio of the Total Labor Force (in %) in Nicaragua in 2006 to that in 2008?
Your response must be concise. 0.98. What is the ratio of the Total Labor Force (in %) of Pakistan in 2006 to that in 2008?
Give a very brief answer. 0.97. What is the ratio of the Total Labor Force (in %) of Serbia in 2006 to that in 2008?
Your answer should be very brief. 0.98. What is the ratio of the Total Labor Force (in %) in Nicaragua in 2006 to that in 2009?
Your answer should be compact. 0.97. What is the ratio of the Total Labor Force (in %) of Pakistan in 2006 to that in 2009?
Offer a terse response. 0.92. What is the ratio of the Total Labor Force (in %) of Serbia in 2006 to that in 2009?
Offer a very short reply. 1.01. What is the ratio of the Total Labor Force (in %) in High income: nonOECD in 2007 to that in 2008?
Provide a succinct answer. 1. What is the ratio of the Total Labor Force (in %) of Nicaragua in 2007 to that in 2008?
Your answer should be compact. 0.99. What is the ratio of the Total Labor Force (in %) in Pakistan in 2007 to that in 2008?
Your answer should be very brief. 0.98. What is the ratio of the Total Labor Force (in %) of Serbia in 2007 to that in 2008?
Give a very brief answer. 1. What is the ratio of the Total Labor Force (in %) of High income: nonOECD in 2007 to that in 2009?
Provide a short and direct response. 1. What is the ratio of the Total Labor Force (in %) of Nicaragua in 2007 to that in 2009?
Your answer should be compact. 0.98. What is the ratio of the Total Labor Force (in %) in Pakistan in 2007 to that in 2009?
Your response must be concise. 0.93. What is the ratio of the Total Labor Force (in %) in Serbia in 2007 to that in 2009?
Make the answer very short. 1.03. What is the ratio of the Total Labor Force (in %) of Pakistan in 2008 to that in 2009?
Your response must be concise. 0.94. What is the ratio of the Total Labor Force (in %) in Serbia in 2008 to that in 2009?
Keep it short and to the point. 1.03. What is the difference between the highest and the second highest Total Labor Force (in %) of High income: nonOECD?
Offer a very short reply. 0.05. What is the difference between the highest and the second highest Total Labor Force (in %) of Serbia?
Offer a terse response. 0. What is the difference between the highest and the lowest Total Labor Force (in %) of High income: nonOECD?
Provide a short and direct response. 2.02. What is the difference between the highest and the lowest Total Labor Force (in %) of Nicaragua?
Give a very brief answer. 5.5. What is the difference between the highest and the lowest Total Labor Force (in %) in Pakistan?
Your answer should be compact. 6.7. What is the difference between the highest and the lowest Total Labor Force (in %) of Serbia?
Ensure brevity in your answer.  1.3. 